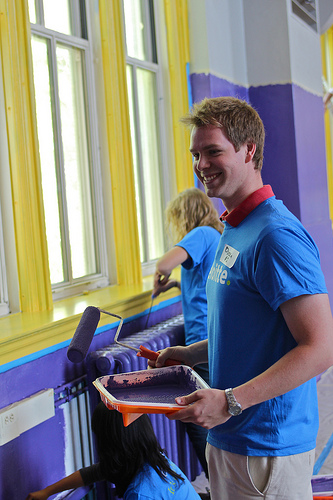<image>
Can you confirm if the woman is to the left of the wall? No. The woman is not to the left of the wall. From this viewpoint, they have a different horizontal relationship. Where is the man in relation to the paint? Is it under the paint? No. The man is not positioned under the paint. The vertical relationship between these objects is different. 